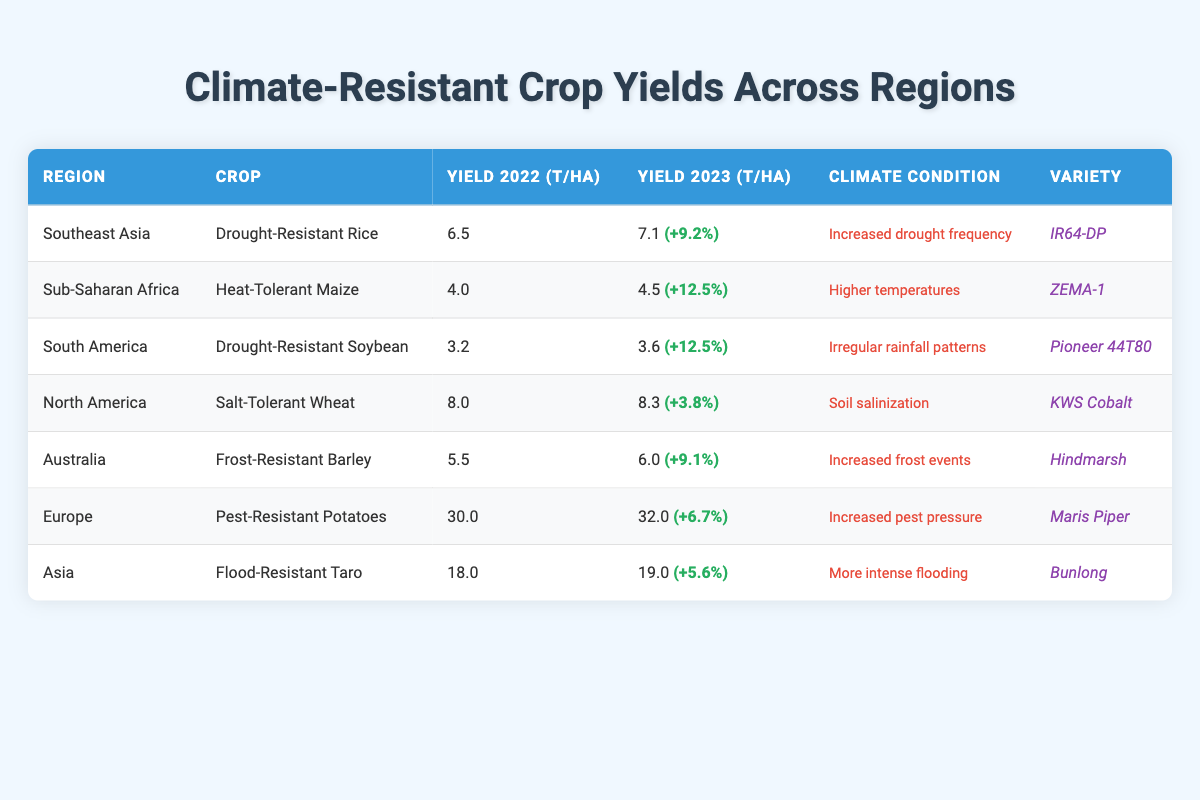What is the yield per hectare of Drought-Resistant Rice in 2023? From the table, under the crop "Drought-Resistant Rice" for the region "Southeast Asia", the yield per hectare for 2023 is presented as 7.1.
Answer: 7.1 Which region has the highest yield for 2023? By looking at the yield per hectare for 2023 across all regions, the highest value is 32.0 for "Pest-Resistant Potatoes" in Europe.
Answer: Europe What is the percentage increase in yield for Heat-Tolerant Maize from 2022 to 2023? For "Heat-Tolerant Maize" in Sub-Saharan Africa, the yield increased from 4.0 in 2022 to 4.5 in 2023. The percentage increase is calculated as ((4.5 - 4.0) / 4.0) * 100 = 12.5%.
Answer: 12.5% Is the yield of Salt-Tolerant Wheat in 2023 higher than that in 2022? The yield for Salt-Tolerant Wheat in 2023 is 8.3, while in 2022, it was 8.0. Since 8.3 > 8.0, the yield in 2023 is indeed higher.
Answer: Yes What is the average yield per hectare for all crops in 2023? The yields in 2023 are: 7.1, 4.5, 3.6, 8.3, 6.0, 32.0, and 19.0. The sum is 81.5 and there are 7 regions, so the average is 81.5 / 7 = 11.64.
Answer: 11.64 Which crop showed the smallest yield increase from 2022 to 2023? The yield increase for each crop is as follows: Drought-Resistant Rice (+9.2%), Heat-Tolerant Maize (+12.5%), Drought-Resistant Soybean (+12.5%), Salt-Tolerant Wheat (+3.8%), Frost-Resistant Barley (+9.1%), Pest-Resistant Potatoes (+6.7%), Flood-Resistant Taro (+5.6%). The smallest is for Salt-Tolerant Wheat.
Answer: Salt-Tolerant Wheat In which region is the climate condition "More intense flooding" associated? According to the table, the climate condition "More intense flooding" is associated with the region of Asia, specifically with the crop "Flood-Resistant Taro".
Answer: Asia What is the total yield per hectare of the crops listed from North America and Europe in 2023? The yield per hectare for North America (Salt-Tolerant Wheat) is 8.3 and for Europe (Pest-Resistant Potatoes) is 32.0. The total is 8.3 + 32.0 = 40.3.
Answer: 40.3 Which crop has the lowest yield in 2022? The yields in 2022 were 6.5, 4.0, 3.2, 8.0, 5.5, 30.0, and 18.0. The lowest yield is 3.2 for Drought-Resistant Soybean in South America.
Answer: Drought-Resistant Soybean How many crops had an increase in yield greater than 10% from 2022 to 2023? The crops with their percentage increases are: Drought-Resistant Rice (+9.2%), Heat-Tolerant Maize (+12.5%), Drought-Resistant Soybean (+12.5%), Salt-Tolerant Wheat (+3.8%), Frost-Resistant Barley (+9.1%), Pest-Resistant Potatoes (+6.7%), Flood-Resistant Taro (+5.6%). Only Heat-Tolerant Maize and Drought-Resistant Soybean had increases greater than 10%. So, there are 2 crops.
Answer: 2 